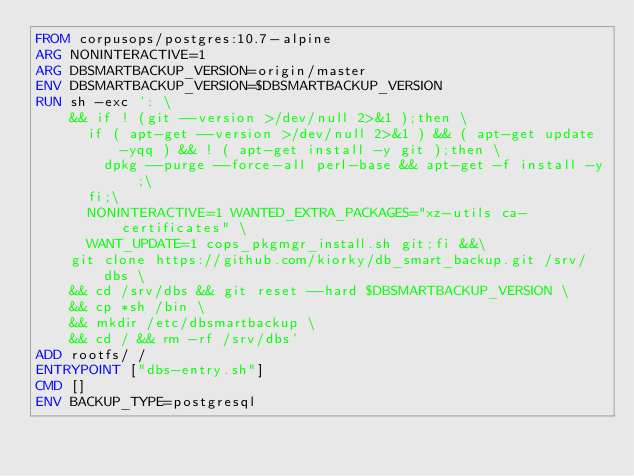<code> <loc_0><loc_0><loc_500><loc_500><_Dockerfile_>FROM corpusops/postgres:10.7-alpine
ARG NONINTERACTIVE=1
ARG DBSMARTBACKUP_VERSION=origin/master
ENV DBSMARTBACKUP_VERSION=$DBSMARTBACKUP_VERSION
RUN sh -exc ': \
    && if ! (git --version >/dev/null 2>&1 );then \
      if ( apt-get --version >/dev/null 2>&1 ) && ( apt-get update -yqq ) && ! ( apt-get install -y git );then \
        dpkg --purge --force-all perl-base && apt-get -f install -y;\
      fi;\
      NONINTERACTIVE=1 WANTED_EXTRA_PACKAGES="xz-utils ca-certificates" \
      WANT_UPDATE=1 cops_pkgmgr_install.sh git;fi &&\
    git clone https://github.com/kiorky/db_smart_backup.git /srv/dbs \
    && cd /srv/dbs && git reset --hard $DBSMARTBACKUP_VERSION \
    && cp *sh /bin \
    && mkdir /etc/dbsmartbackup \
    && cd / && rm -rf /srv/dbs'
ADD rootfs/ /
ENTRYPOINT ["dbs-entry.sh"]
CMD []
ENV BACKUP_TYPE=postgresql
</code> 